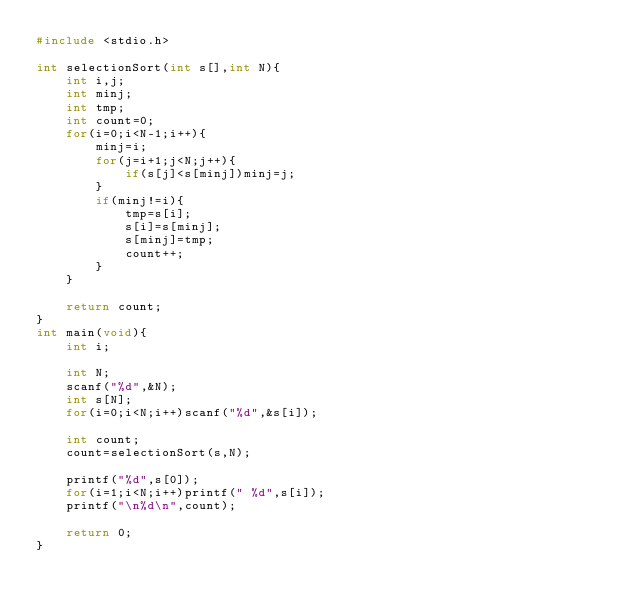Convert code to text. <code><loc_0><loc_0><loc_500><loc_500><_C_>#include <stdio.h>

int selectionSort(int s[],int N){
    int i,j;
    int minj;
    int tmp;
    int count=0;
    for(i=0;i<N-1;i++){
        minj=i;
        for(j=i+1;j<N;j++){
            if(s[j]<s[minj])minj=j;
        }
        if(minj!=i){
            tmp=s[i];
            s[i]=s[minj];
            s[minj]=tmp;
            count++;
        }
    }

    return count;
}
int main(void){
    int i;
    
    int N;
    scanf("%d",&N);
    int s[N];
    for(i=0;i<N;i++)scanf("%d",&s[i]);
    
    int count;
    count=selectionSort(s,N);
    
    printf("%d",s[0]);
    for(i=1;i<N;i++)printf(" %d",s[i]);
    printf("\n%d\n",count);
    
    return 0;
}
</code> 